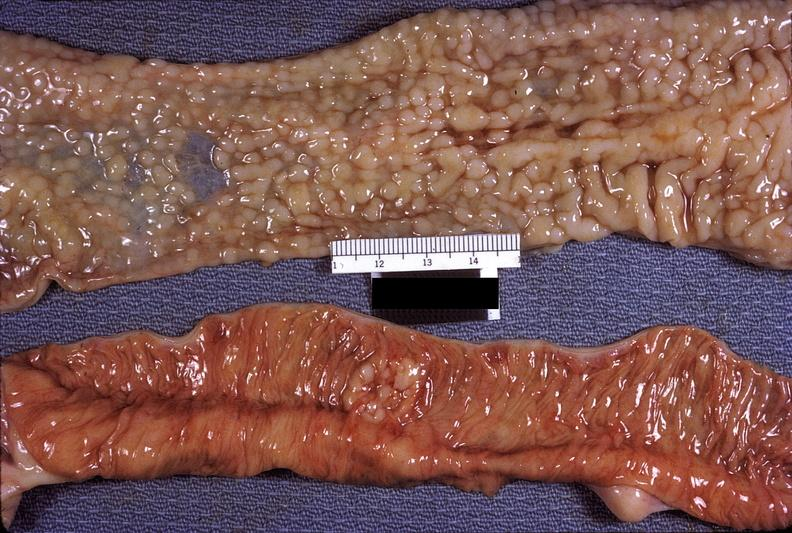what is present?
Answer the question using a single word or phrase. Gastrointestinal 